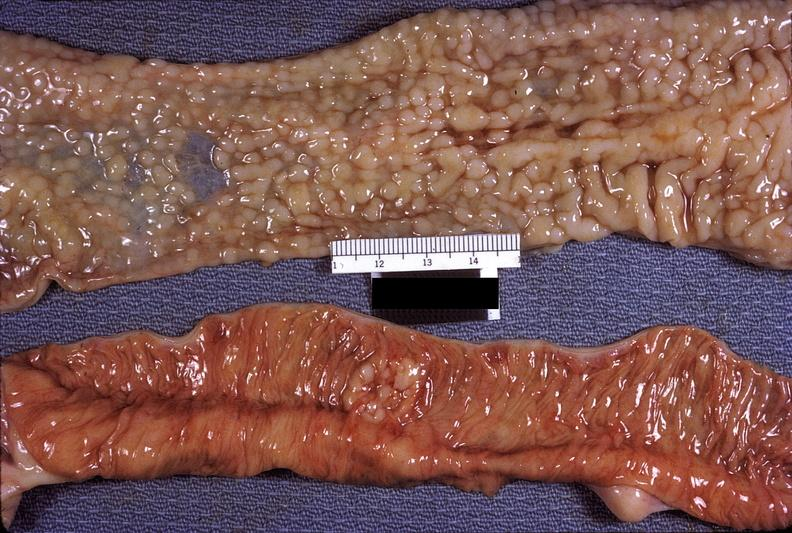what is present?
Answer the question using a single word or phrase. Gastrointestinal 